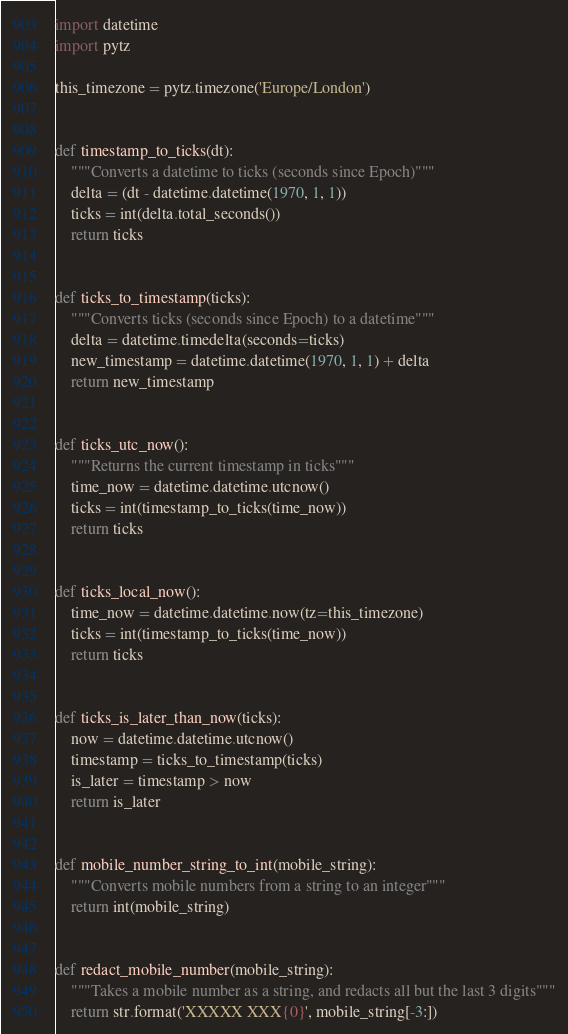Convert code to text. <code><loc_0><loc_0><loc_500><loc_500><_Python_>import datetime
import pytz

this_timezone = pytz.timezone('Europe/London')


def timestamp_to_ticks(dt):
    """Converts a datetime to ticks (seconds since Epoch)"""
    delta = (dt - datetime.datetime(1970, 1, 1))
    ticks = int(delta.total_seconds())
    return ticks


def ticks_to_timestamp(ticks):
    """Converts ticks (seconds since Epoch) to a datetime"""
    delta = datetime.timedelta(seconds=ticks)
    new_timestamp = datetime.datetime(1970, 1, 1) + delta
    return new_timestamp


def ticks_utc_now():
    """Returns the current timestamp in ticks"""
    time_now = datetime.datetime.utcnow()
    ticks = int(timestamp_to_ticks(time_now))
    return ticks


def ticks_local_now():
    time_now = datetime.datetime.now(tz=this_timezone)
    ticks = int(timestamp_to_ticks(time_now))
    return ticks


def ticks_is_later_than_now(ticks):
    now = datetime.datetime.utcnow()
    timestamp = ticks_to_timestamp(ticks)
    is_later = timestamp > now
    return is_later


def mobile_number_string_to_int(mobile_string):
    """Converts mobile numbers from a string to an integer"""
    return int(mobile_string)


def redact_mobile_number(mobile_string):
    """Takes a mobile number as a string, and redacts all but the last 3 digits"""
    return str.format('XXXXX XXX{0}', mobile_string[-3:])</code> 